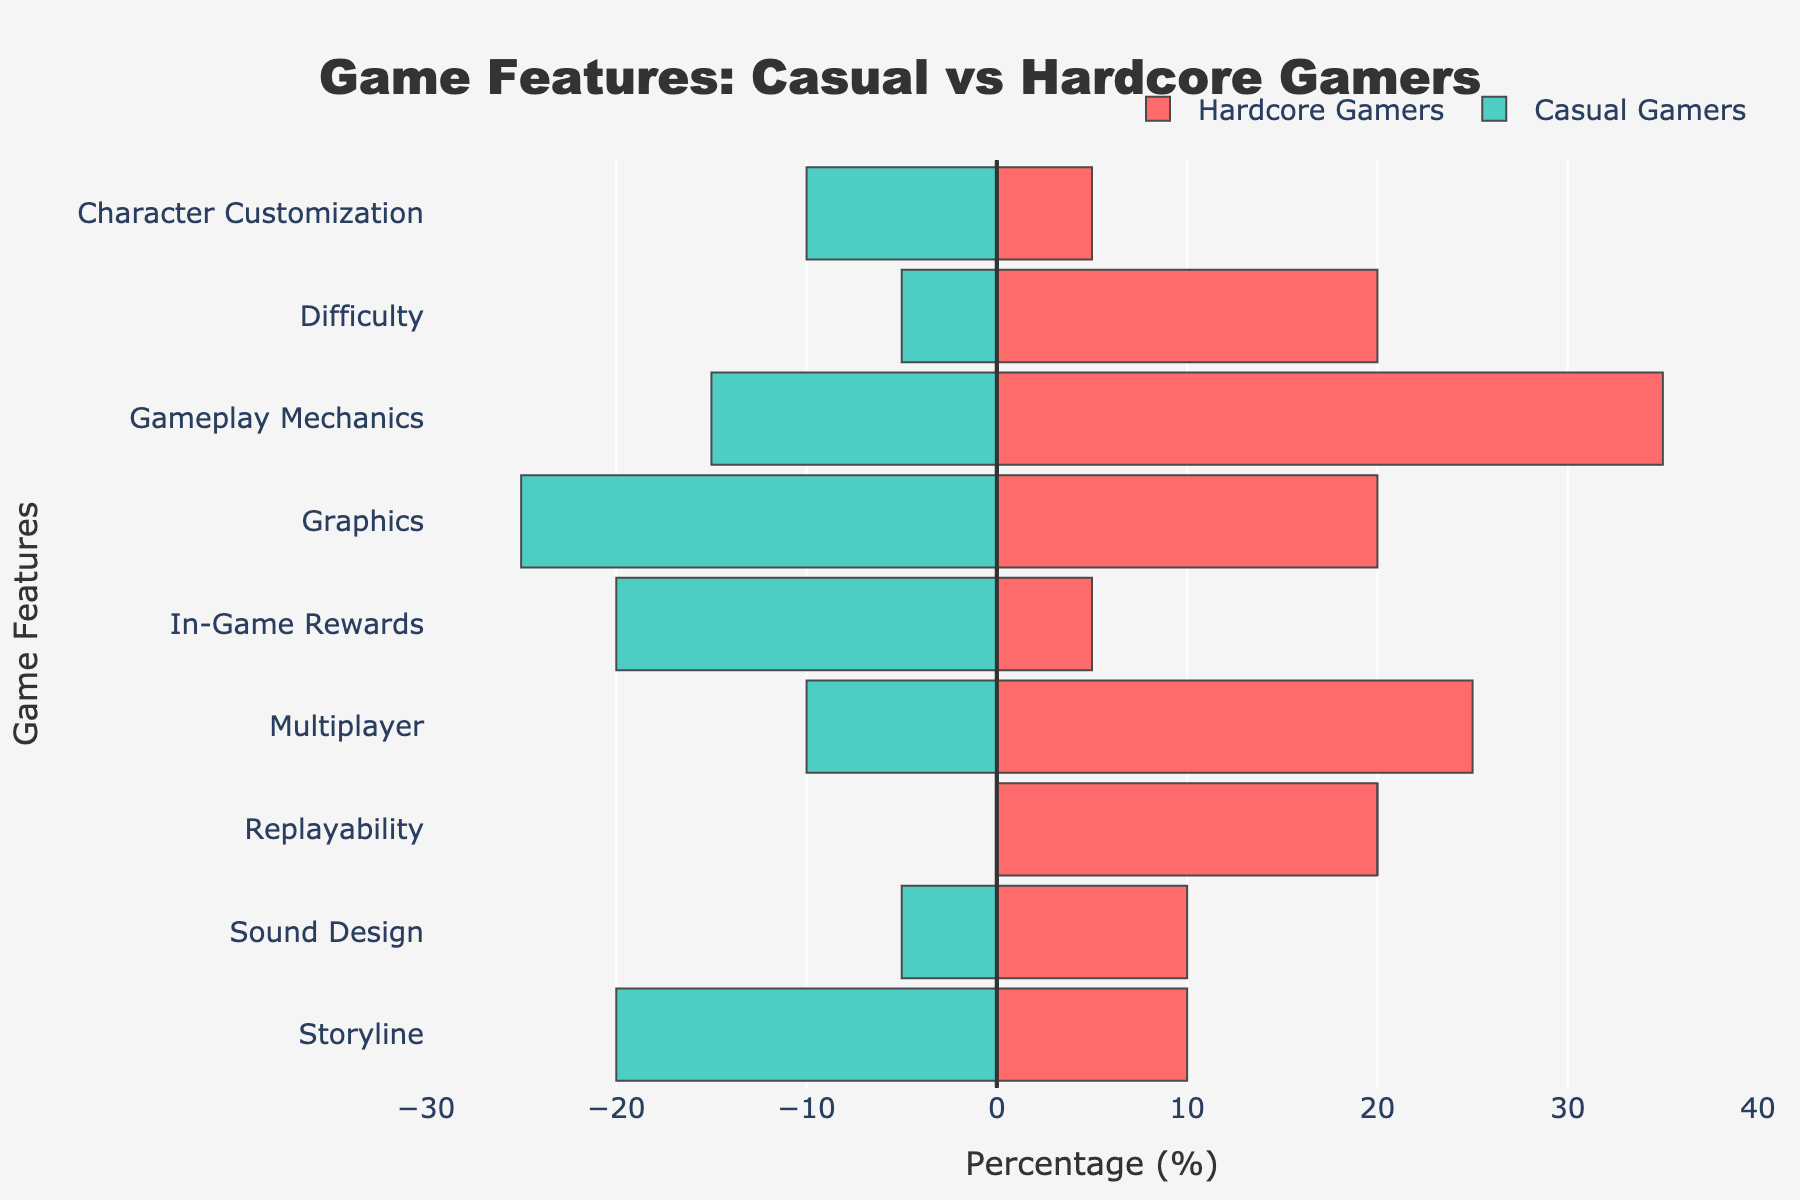What percentage of Casual Gamers prioritize Graphics over Gameplay Mechanics? First, identify the percentages of Casual Gamers who prioritize Graphics and Gameplay Mechanics. The percentages are 25% and 15% respectively. Subtract the Gameplay Mechanics percentage from the Graphics percentage: 25% - 15% = 10%
Answer: 10% Which group prioritizes Multiplayer the most? Compare the percentages for Multiplayer between Casual Gamers and Hardcore Gamers. Casual Gamers have 10% while Hardcore Gamers have 25%. Thus, Hardcore Gamers prioritize Multiplayer the most.
Answer: Hardcore Gamers Is the percentage of Hardcore Gamers who prioritize Replayability greater than those who prioritize Difficulty? Check the percentages for both features among Hardcore Gamers. Replayability is at 20% and Difficulty is also at 20%. Thus, they are equal.
Answer: Equal How does the importance of In-Game Rewards differ between Casual and Hardcore Gamers? Compare the percentages for In-Game Rewards between the groups. Casual Gamers have 20%, and Hardcore Gamers have 5%. The difference is 20% - 5% = 15%. Casual Gamers prioritize In-Game Rewards 15% more than Hardcore Gamers.
Answer: 15% Which feature has the largest difference in priority between Casual and Hardcore Gamers, and what is the difference? Compute the absolute differences for each feature by subtracting percentages and taking the absolute value. The differences are: Graphics (5%), Gameplay Mechanics (20%), Storyline (10%), Multiplayer (15%), In-Game Rewards (15%), Character Customization (5%), Replayability (20%), Sound Design (5%), Difficulty (15%). The largest difference is for Gameplay Mechanics and Replayability, both at 20%.
Answer: Gameplay Mechanics and Replayability, 20% How many features are more important for Hardcore Gamers than for Casual Gamers? Compare the percentages for each feature between the two groups: Graphics (Casual 25% > Hardcore 20%), Gameplay Mechanics (Casual 15% < Hardcore 35%), Storyline (Casual 20% > Hardcore 10%), Multiplayer (Casual 10% < Hardcore 25%), In-Game Rewards (Casual 20% > Hardcore 5%), Character Customization (Casual 10% > Hardcore 5%), Replayability (Casual 0% < Hardcore 20%), Sound Design (Casual 5% < Hardcore 10%), Difficulty (Casual 5% < Hardcore 20%). Hardcore Gamers prioritize more features in four cases.
Answer: 4 What is the total percentage of features prioritized by Casual Gamers that add up to more than 15%? Identify the features where Casual Gamers have percentages greater than 15%: Graphics (25%), StoryLine (20%), In-Game Rewards (20%). Sum these percentages: 25% + 20% + 20% = 65%.
Answer: 65% Which feature do both Casual and Hardcore Gamers prioritize equally? Examine the features for equality in percentages: None of the features have equal percentages for both groups.
Answer: None 